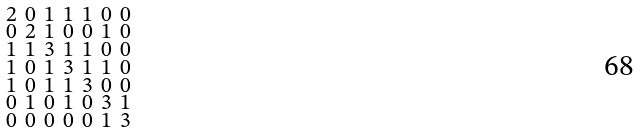<formula> <loc_0><loc_0><loc_500><loc_500>\begin{smallmatrix} 2 & 0 & 1 & 1 & 1 & 0 & 0 \\ 0 & 2 & 1 & 0 & 0 & 1 & 0 \\ 1 & 1 & 3 & 1 & 1 & 0 & 0 \\ 1 & 0 & 1 & 3 & 1 & 1 & 0 \\ 1 & 0 & 1 & 1 & 3 & 0 & 0 \\ 0 & 1 & 0 & 1 & 0 & 3 & 1 \\ 0 & 0 & 0 & 0 & 0 & 1 & 3 \end{smallmatrix}</formula> 